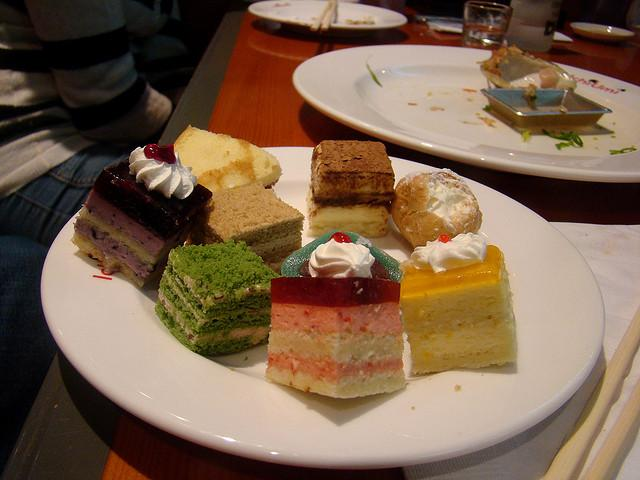What is the English translation of the French name for these? small oven 